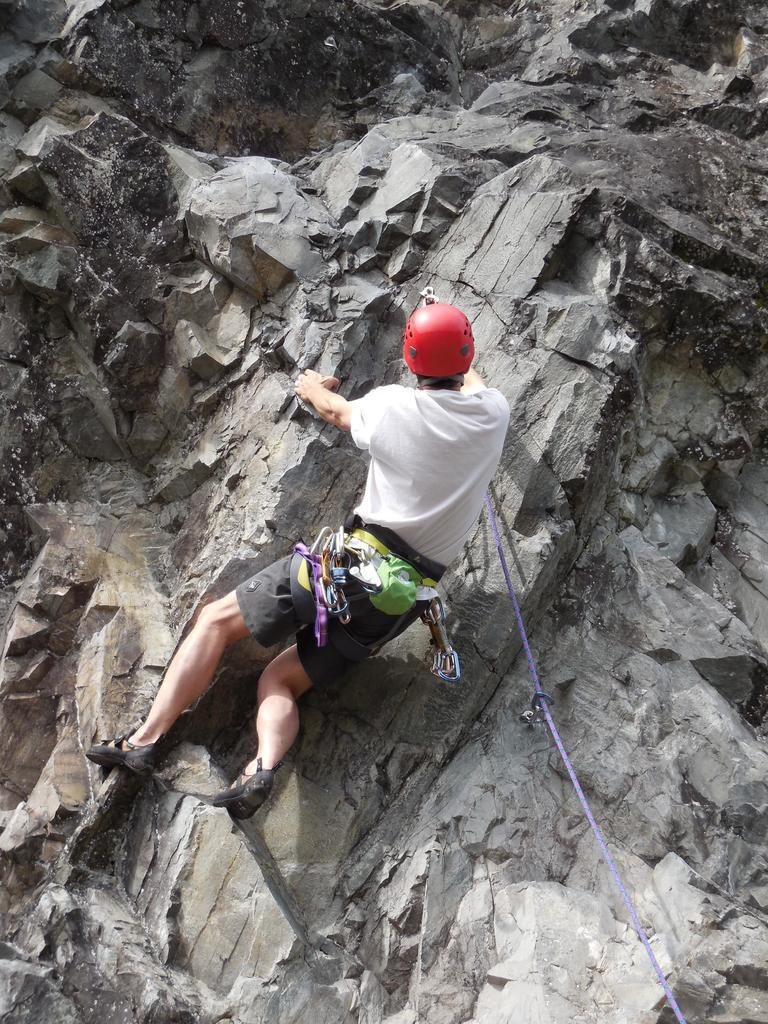What is the main subject of the image? There is a person in the image. What is the person wearing on their head? The person is wearing a red color helmet. What type of clothing is the person wearing on their upper body? The person is wearing a white color t-shirt. What activity is the person engaged in? The person is climbing a mountain. How does the person comfort the crying person on the sidewalk in the image? There is no crying person on the sidewalk in the image, and the person in the image is climbing a mountain, not comforting anyone. 